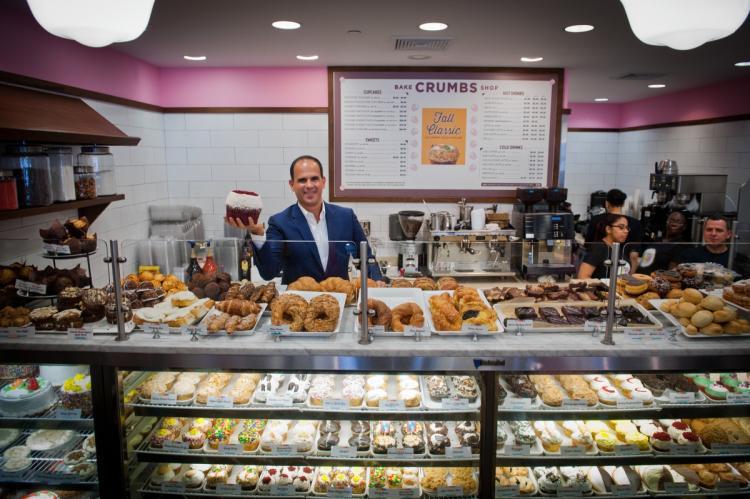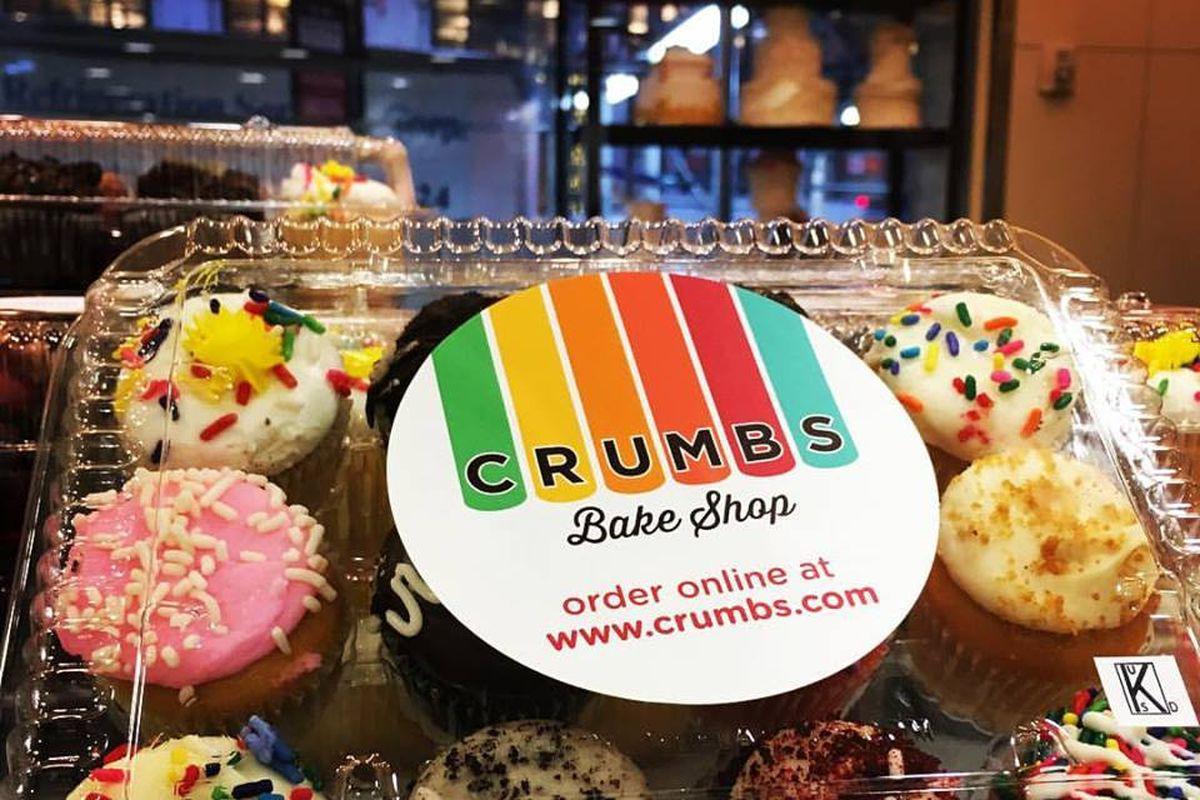The first image is the image on the left, the second image is the image on the right. Given the left and right images, does the statement "An image shows at least one person on the sidewalk in front of the shop in the daytime." hold true? Answer yes or no. No. 